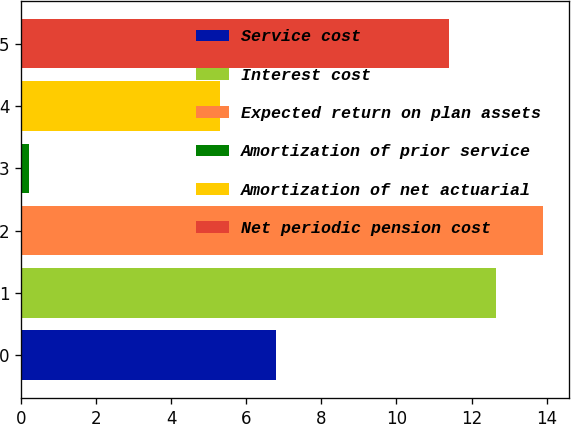Convert chart. <chart><loc_0><loc_0><loc_500><loc_500><bar_chart><fcel>Service cost<fcel>Interest cost<fcel>Expected return on plan assets<fcel>Amortization of prior service<fcel>Amortization of net actuarial<fcel>Net periodic pension cost<nl><fcel>6.8<fcel>12.65<fcel>13.9<fcel>0.2<fcel>5.3<fcel>11.4<nl></chart> 